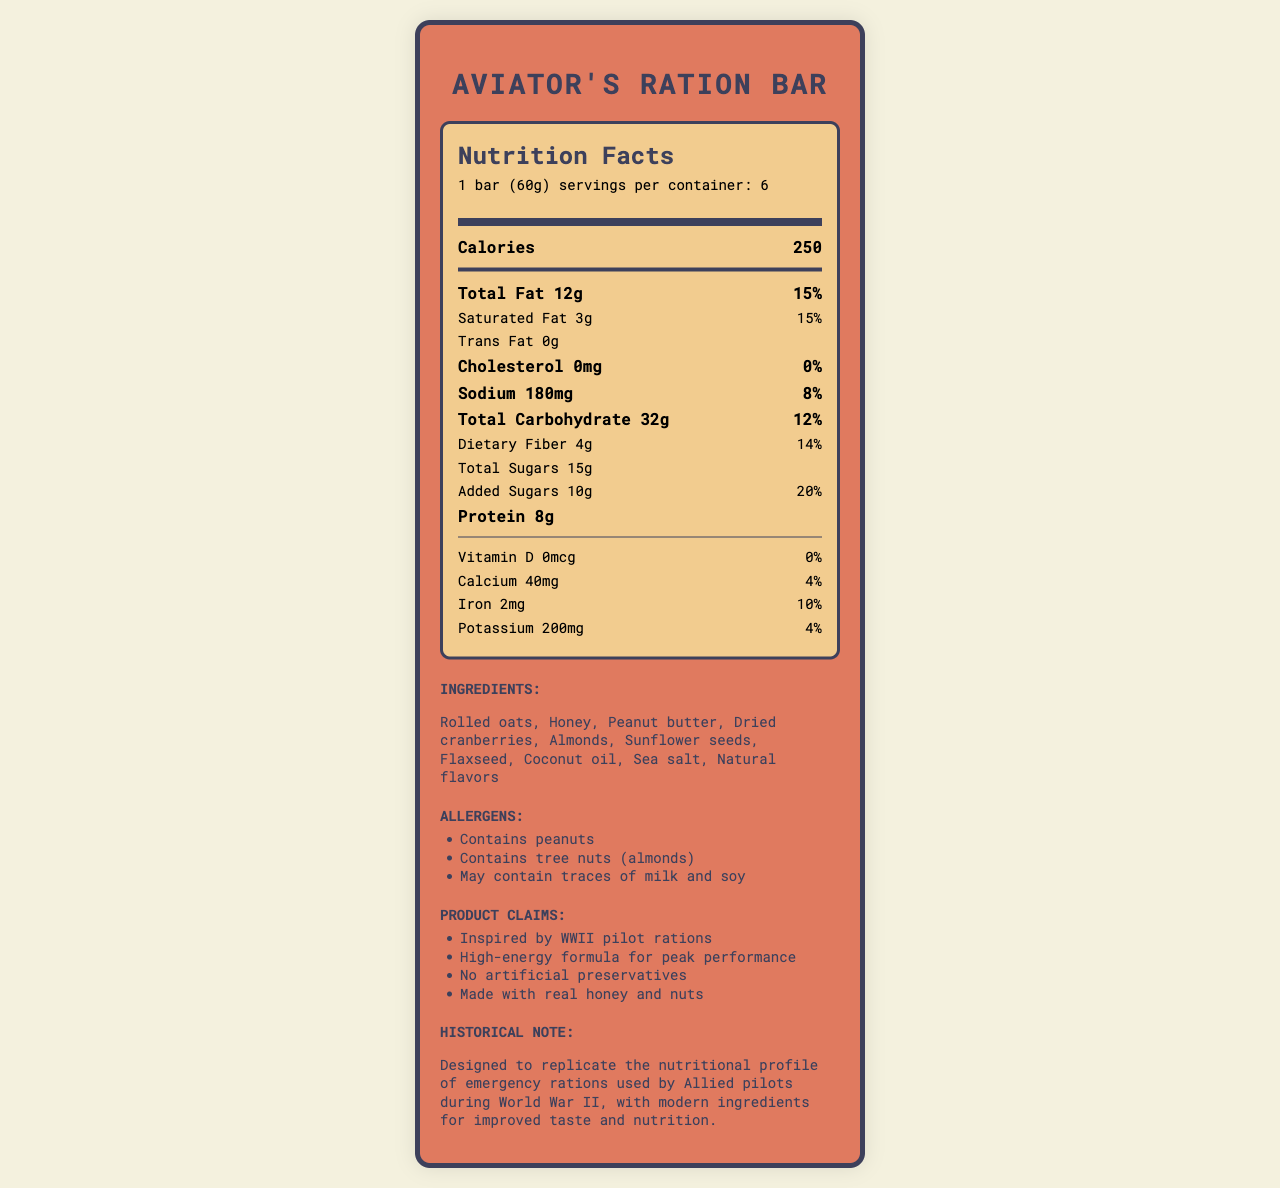what is the product name? The product name is clearly stated at the top of the document in the title section.
Answer: Aviator's Ration Bar what is the serving size per bar? The serving size per bar is listed under the "Nutrition Facts" section header.
Answer: 1 bar (60g) how many calories are in one bar? The number of calories per bar is prominently displayed in the "Nutrition Facts" section.
Answer: 250 name two ingredients included in the Aviator's Ration Bar. These ingredients are listed in the "Ingredients" section.
Answer: Rolled oats, Honey what is the total fat content in one bar? The total fat content is shown in the "Nutrition Facts" section.
Answer: 12g how many grams of protein does one bar contain? This information is detailed under the "Nutrition Facts" section.
Answer: 8g which vitamin has no contribution to the daily value? The "Vitamin D" section shows 0mcg and 0% of the daily value.
Answer: Vitamin D what is the percent daily value of added sugars? The percent daily value for added sugars is given as 20% in the "Nutrition Facts" section.
Answer: 20% how much iron is in one bar? The iron content is listed as 2mg under the "Nutrition Facts" section.
Answer: 2mg how many servings are there per container? This information is listed at the top of the "Nutrition Facts" section.
Answer: 6 What is the historical note about the Aviator's Ration Bar? The historical note is provided in the "Historical Note" section of the document.
Answer: Designed to replicate the nutritional profile of emergency rations used by Allied pilots during World War II, with modern ingredients for improved taste and nutrition. milk and soy are listed under which section? The presence of milk and soy is stated in the "Allergens" section.
Answer: Allergens What is NOT a marketing claim of the Aviator's Ration Bar? A. No artificial preservatives B. High-energy formula C. Contains artificial flavors D. Made with real honey and nuts "Contains artificial flavors" is not listed among the marketing claims; instead, the bar is claimed to have "No artificial preservatives."
Answer: C. Contains artificial flavors Which ingredient appears first in the list? A. Almonds B. Rolled oats C. Flaxseed The first ingredient listed in the "Ingredients" section is "Rolled oats."
Answer: B. Rolled oats Is the Aviator's Ration Bar suitable for someone with peanut allergies? The "Allergens" section notes that the product contains peanuts.
Answer: No Name two places where Aviator's Ration Bar might be sold. These are listed as distribution channels under "Distribution Channels."
Answer: Military and aviation museums, Specialty bookstores carrying WWII literature Summarize the main idea of the document. The main sections of the document are the product's nutrition facts, ingredient list, allergen information, marketing claims, historical note, and distribution channels.
Answer: The document provides the nutrition facts and other key information about the Aviator's Ration Bar, a WWII-themed energy bar inspired by pilot rations. This product contains ingredients such as rolled oats and honey, and it is marketed for high-energy performance with no artificial preservatives. It also includes historical notes about the inspiration for the product and details potential allergens. The bar is targeted at history enthusiasts, aviation buffs, and outdoor adventurers and is distributed in military museums and specialty bookstores. What inspired the design of the Aviator's Ration Bar? The "Historical Note" mentions that the bar is designed to replicate the nutritional profile of emergency rations used by Allied pilots during World War II.
Answer: World War II pilot rations Are artificial preservatives used in the Aviator's Ration Bar? According to the "Marketing Claims" section, the bar contains "No artificial preservatives."
Answer: No Is the trans fat amount provided? The "Nutrition Facts" section states that the trans fat content is 0g.
Answer: 0g what is the total carbohydrate content in one bar? The total carbohydrate content is listed under the "Nutrition Facts" section.
Answer: 32g Are there enough details in the document for a nutritional comparison with another similar product? The document only provides nutrition facts for the Aviator's Ration Bar and does not contain information about any other products for comparison.
Answer: No 